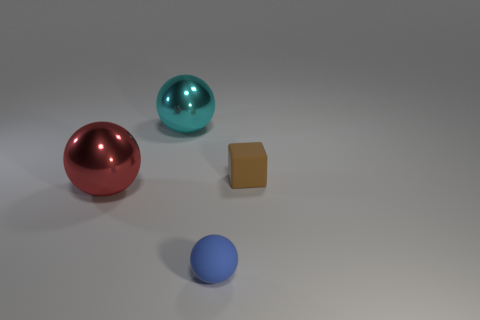Is there another rubber sphere that has the same size as the blue sphere? no 